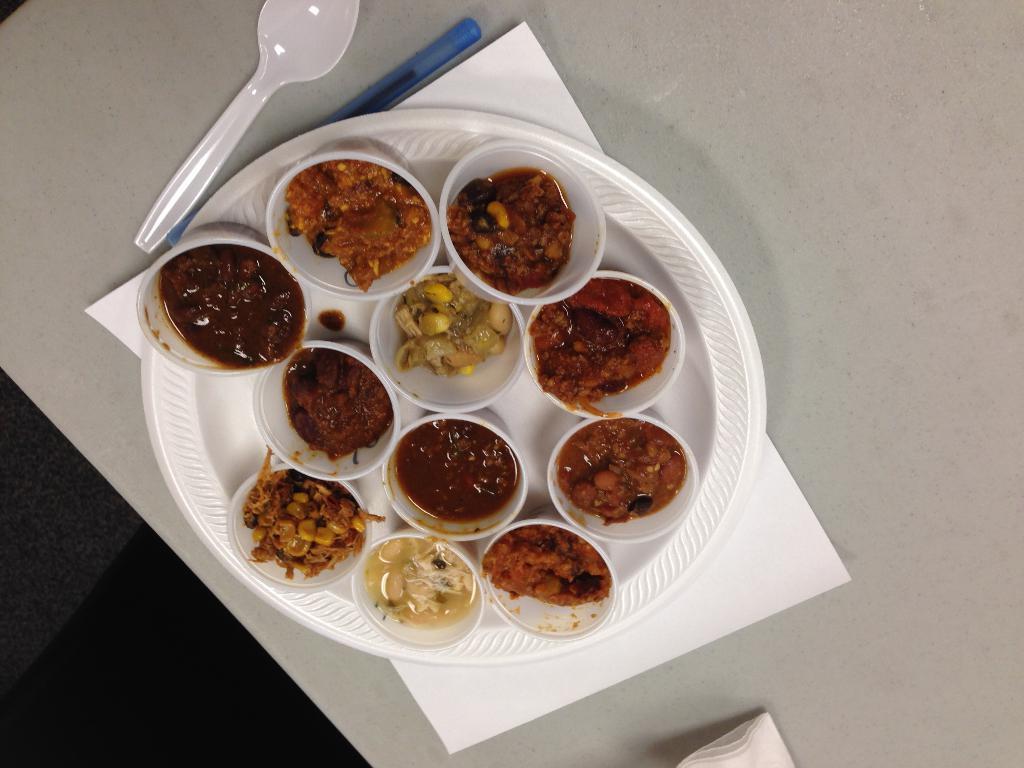Can you describe this image briefly? In this image we can see there are food items in the plate. There is a spoon and a pen. 